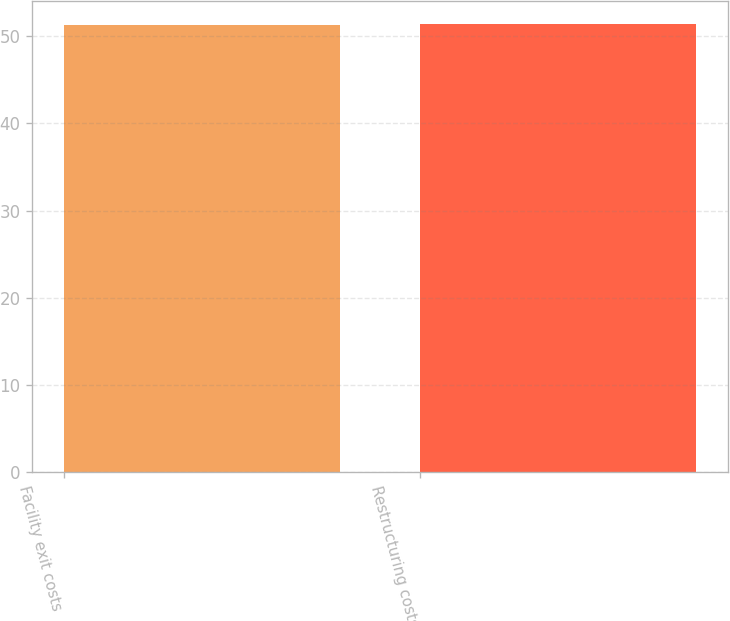Convert chart to OTSL. <chart><loc_0><loc_0><loc_500><loc_500><bar_chart><fcel>Facility exit costs<fcel>Restructuring costs<nl><fcel>51.3<fcel>51.4<nl></chart> 